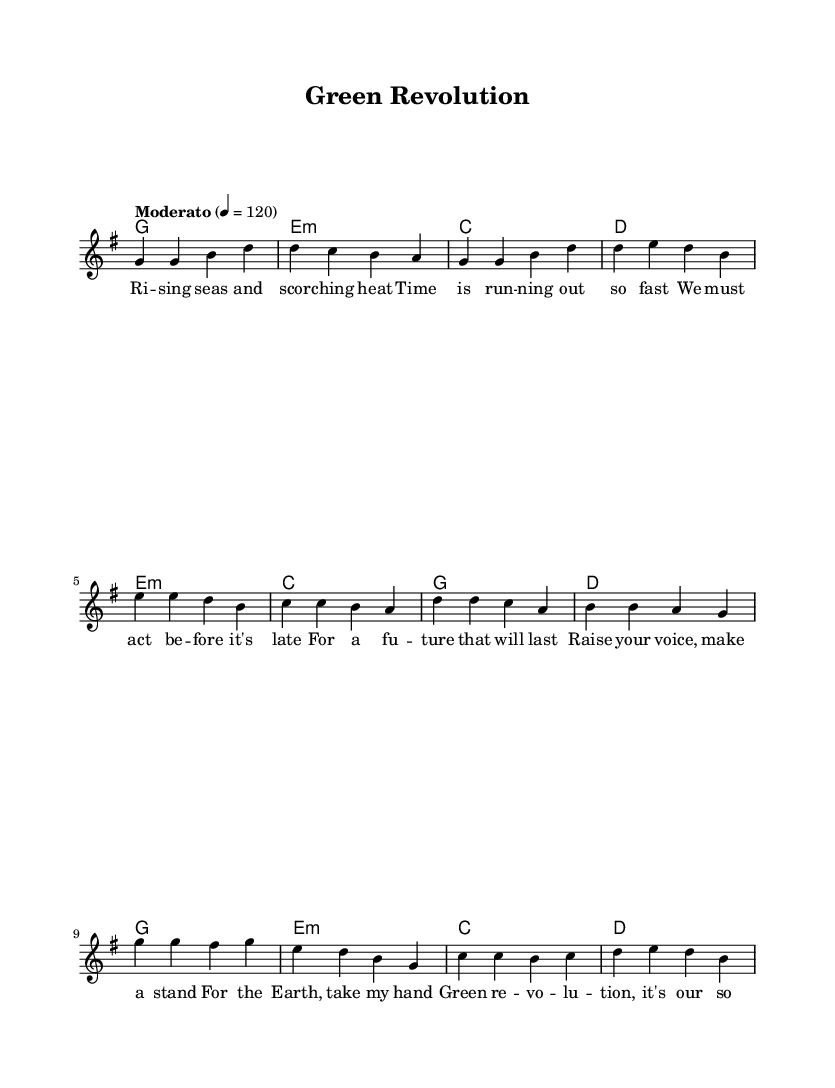What is the key signature of this music? The key signature is G major, which has one sharp (F#). You can determine this by looking at the key signature section of the score at the beginning of the staff.
Answer: G major What is the time signature of the piece? The time signature is 4/4, indicating four beats per measure. This is visually represented at the beginning of the score, where the time signature is placed just after the key signature.
Answer: 4/4 What is the tempo marking given in the score? The tempo marking is "Moderato" and the metronome marking is 4 equals 120. This information is provided at the start of the score and indicates a moderate speed at which the piece should be played.
Answer: Moderato 4 = 120 How many lines are there in the melody portion? There is one line in the melody portion, as indicated by the single staff created for the voice. In this case, each line represents a melodic line to be sung or played.
Answer: One Which harmony follows the first verse? The harmony that follows the first verse is E minor. You can find this by looking at the chord changes that correspond with the lyrics of the verse, where the first chord after the verse is indicated.
Answer: E minor What is the lyrical theme addressed in the chorus? The lyrical theme addressed in the chorus is about a "Green revolution". This is derived from the lyrics provided in the score, where the focus on environmental activism is explicitly indicated.
Answer: Green revolution How does the pre-chorus encourage participation? The pre-chorus encourages participation by inviting listeners to "Raise your voice, make a stand." This is a motivational call found in the lyrics, emphasizing the need for collective action toward environmental issues.
Answer: Raise your voice, make a stand 